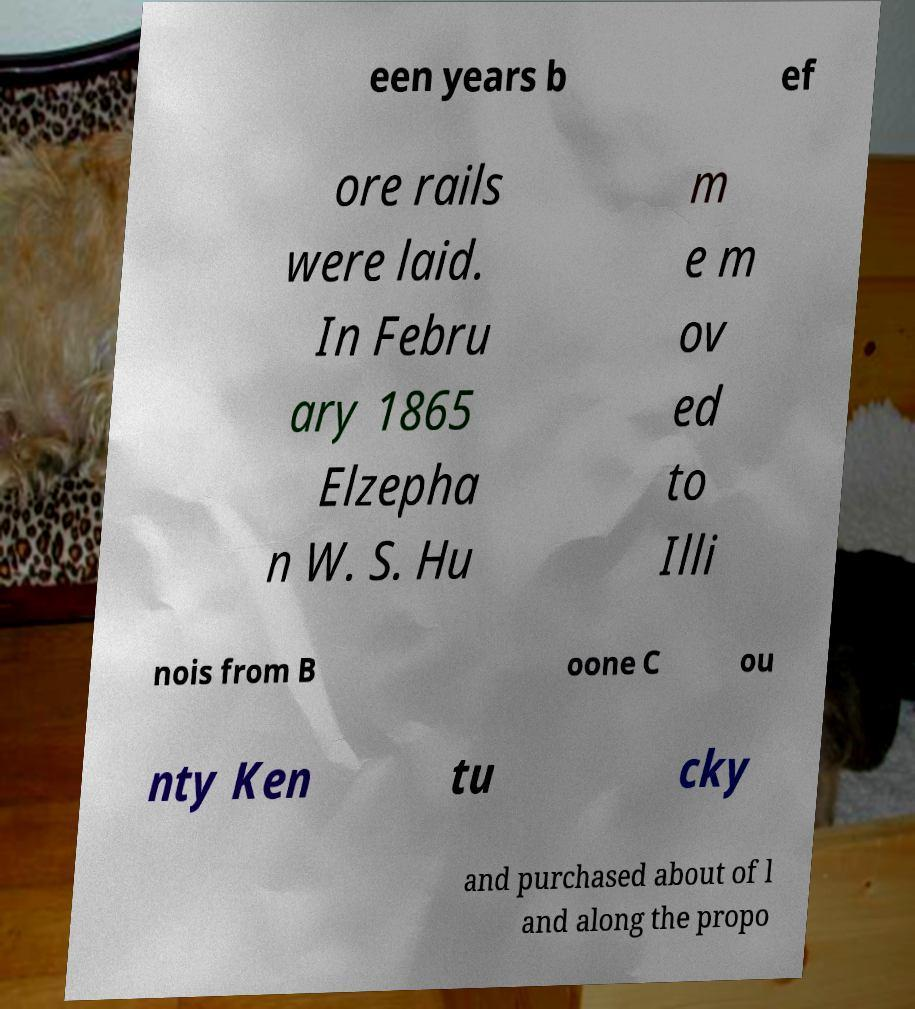Can you accurately transcribe the text from the provided image for me? een years b ef ore rails were laid. In Febru ary 1865 Elzepha n W. S. Hu m e m ov ed to Illi nois from B oone C ou nty Ken tu cky and purchased about of l and along the propo 